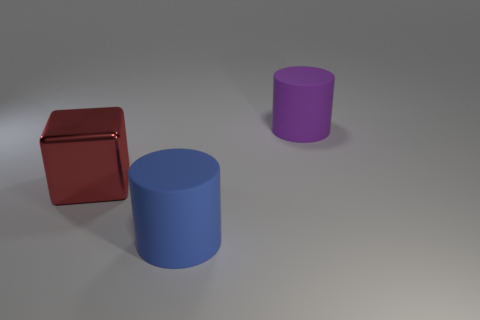What materials do the objects in the image look like they're made from? The objects in the image look like they are rendered digitally, simulating a smooth, matte finish that could be interpreted as a type of plastic or painted wood. 